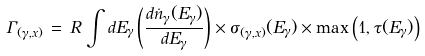<formula> <loc_0><loc_0><loc_500><loc_500>\Gamma _ { ( \gamma , x ) } \, = \, R \, \int d E _ { \gamma } \left ( \frac { d \dot { n } _ { \gamma } ( E _ { \gamma } ) } { d E _ { \gamma } } \right ) \times \sigma _ { ( \gamma , x ) } ( E _ { \gamma } ) \times \max \left ( 1 , \tau ( E _ { \gamma } ) \right )</formula> 